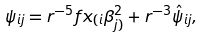<formula> <loc_0><loc_0><loc_500><loc_500>\psi _ { i j } = r ^ { - 5 } f x _ { ( i } \beta _ { j ) } ^ { 2 } + r ^ { - 3 } \hat { \psi } _ { i j } ,</formula> 